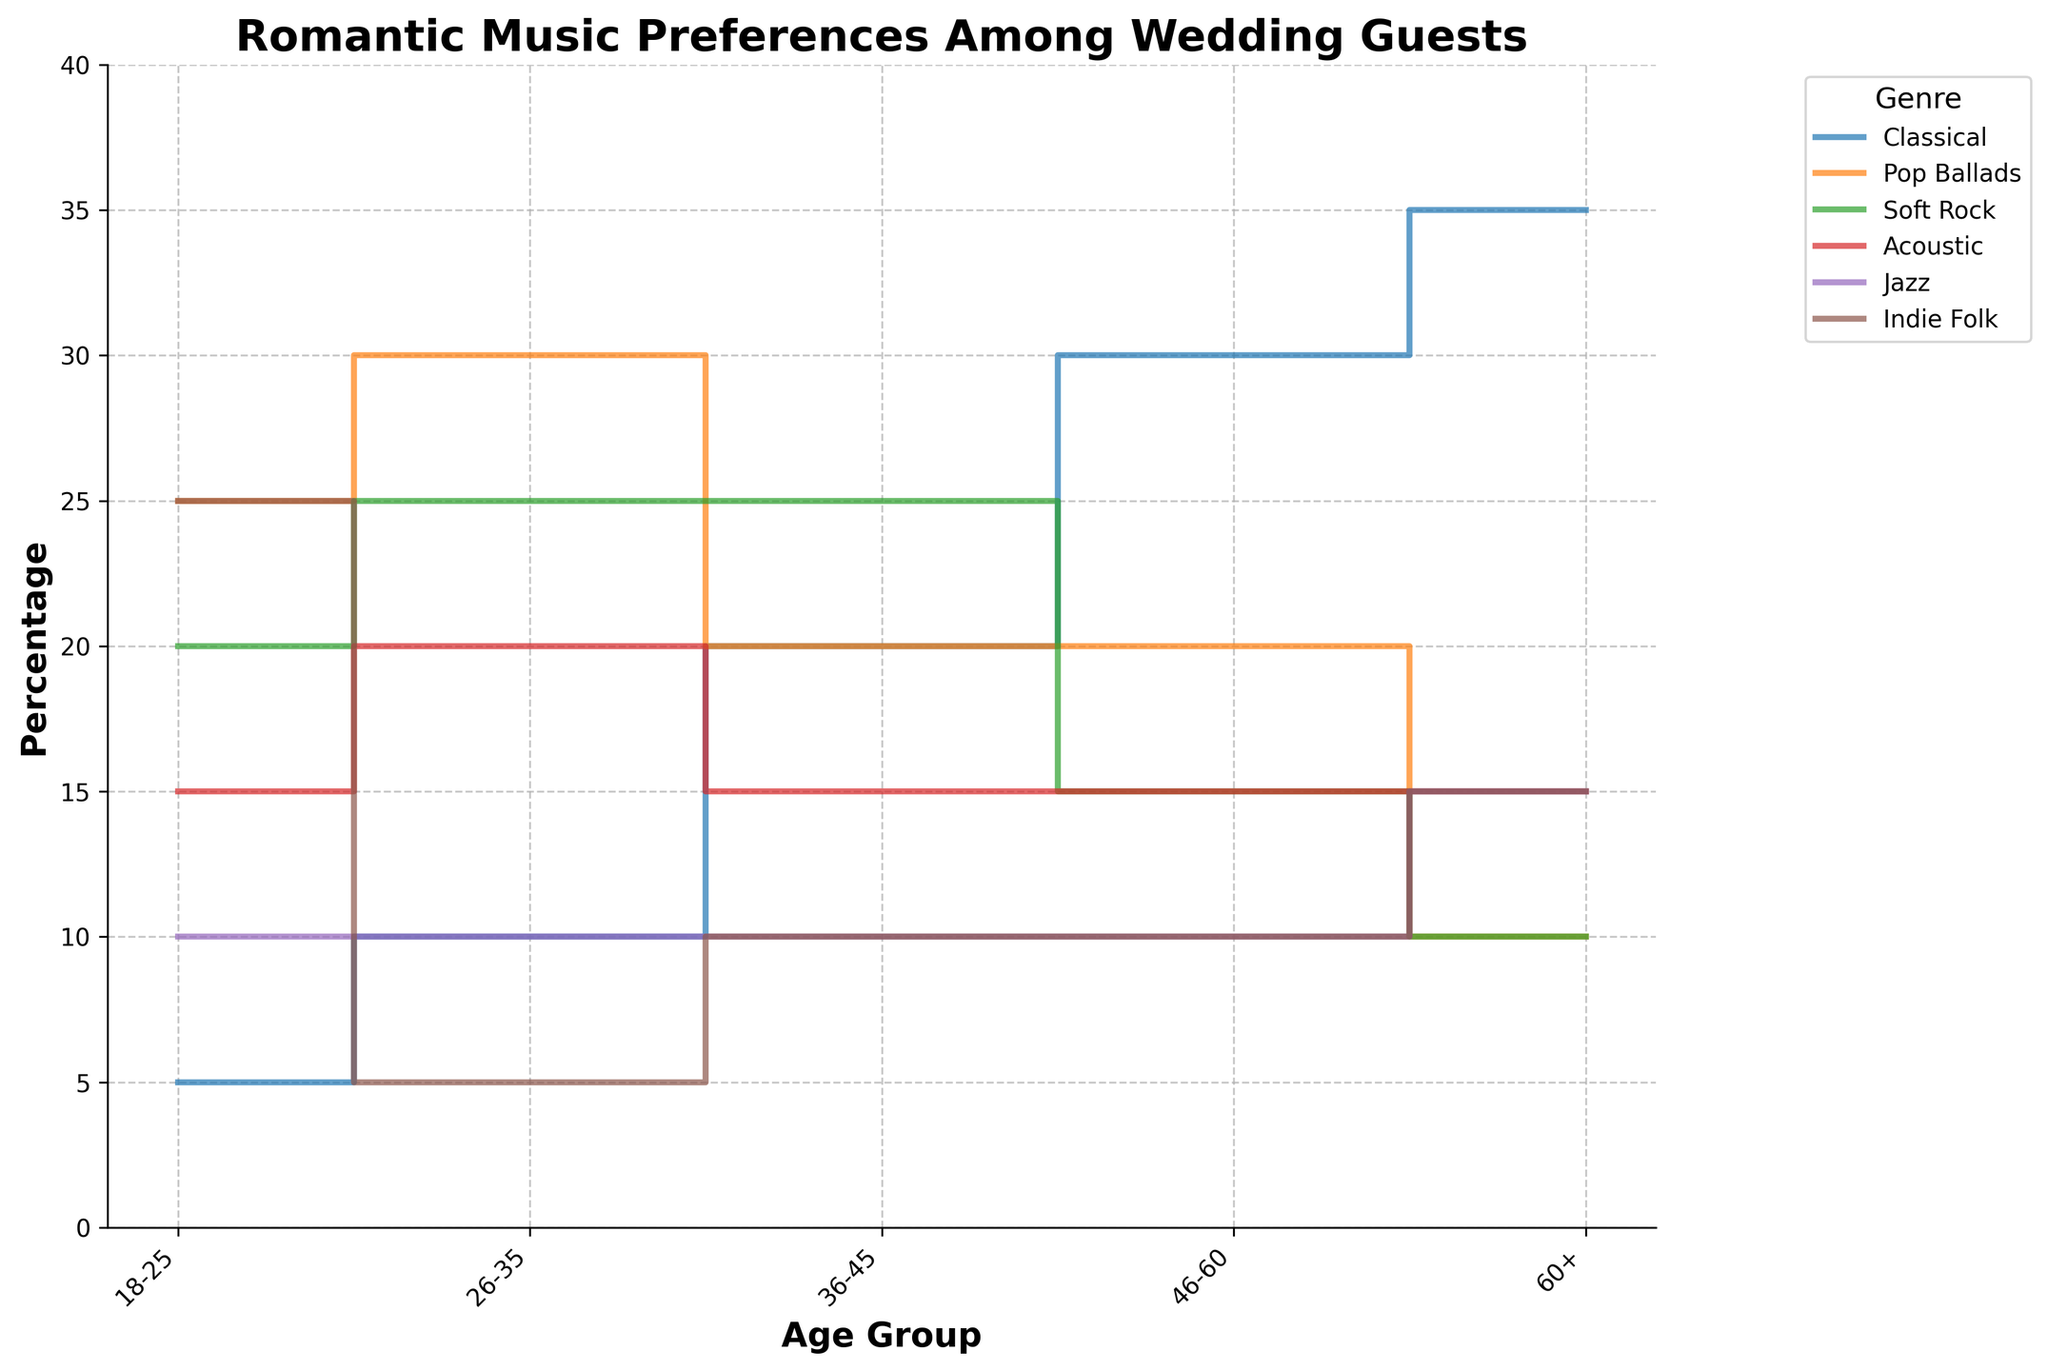What's the title of the figure? The title of the figure is the text that appears prominently at the top of the plot. It provides an overview of what the figure is about. In this case, the title is present at the top and reads "Romantic Music Preferences Among Wedding Guests."
Answer: Romantic Music Preferences Among Wedding Guests What age group has the highest percentage for liking Classical music? To find the age group with the highest percentage for liking Classical music, look at the step plot line representing Classical music and identify the age group where this line reaches its peak value. The peak value for Classical music is at 35% in the 60+ age group.
Answer: 60+ Compare the preferences for Pop Ballads between the 18-25 and 26-35 age groups. Which age group shows a higher percentage? First, identify the percentages for Pop Ballads in both age groups by locating the points on the step plot for each age group. For the 18-25 age group, the percentage is 25%, while for the 26-35 age group, it is 30%. Therefore, the 26-35 age group shows a higher percentage for Pop Ballads.
Answer: 26-35 Which genre shows a fairly consistent preference across all age groups? To determine the genre with a fairly consistent preference, look at the step plot lines and see which one remains relatively stable across all age groups. The Jazz line remains around 10-15% across all age groups, indicating a fairly consistent preference.
Answer: Jazz How much higher is the preference for Classical music in the 46-60 age group compared to the 36-45 age group? Find the percentages for Classical music in both age groups—30% for the 46-60 age group and 20% for the 36-45 age group. Subtract the lower percentage from the higher percentage: 30% - 20% = 10%.
Answer: 10% What is the trend for the preference of Indie Folk music as age increases? Observe the step plot line for Indie Folk music. In the younger age groups (18-25 and 26-35), preferences are higher but drop significantly in the 36-45 age group before becoming stable or increasing slightly again in older age groups (46-60 and 60+).
Answer: Variable with initial peak, drop, then stabilization/increase Which genre has the most significant decrease in preference as age increases from 18-25 to 60+? Examine each genre's step plot line and compare their percentages from 18-25 to 60+. Pop Ballads show the most significant decrease, going from 25% in 18-25 age group to 10% in the 60+ age group, a difference of 15%.
Answer: Pop Ballads If you wanted to play the genre with the overall highest preference among guests aged 26-35, which genre would you choose? Look at the peak percentages for all genres within the 26-35 age group. The highest percentage is for Pop Ballads at 30%. Thus, Pop Ballads is the genre to choose.
Answer: Pop Ballads 